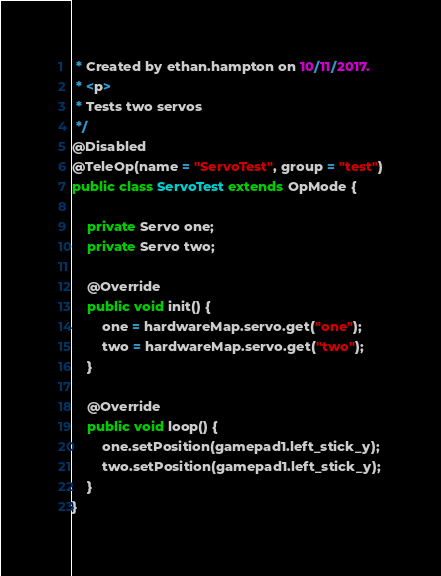Convert code to text. <code><loc_0><loc_0><loc_500><loc_500><_Java_> * Created by ethan.hampton on 10/11/2017.
 * <p>
 * Tests two servos
 */
@Disabled
@TeleOp(name = "ServoTest", group = "test")
public class ServoTest extends OpMode {

    private Servo one;
    private Servo two;

    @Override
    public void init() {
        one = hardwareMap.servo.get("one");
        two = hardwareMap.servo.get("two");
    }

    @Override
    public void loop() {
        one.setPosition(gamepad1.left_stick_y);
        two.setPosition(gamepad1.left_stick_y);
    }
}
</code> 